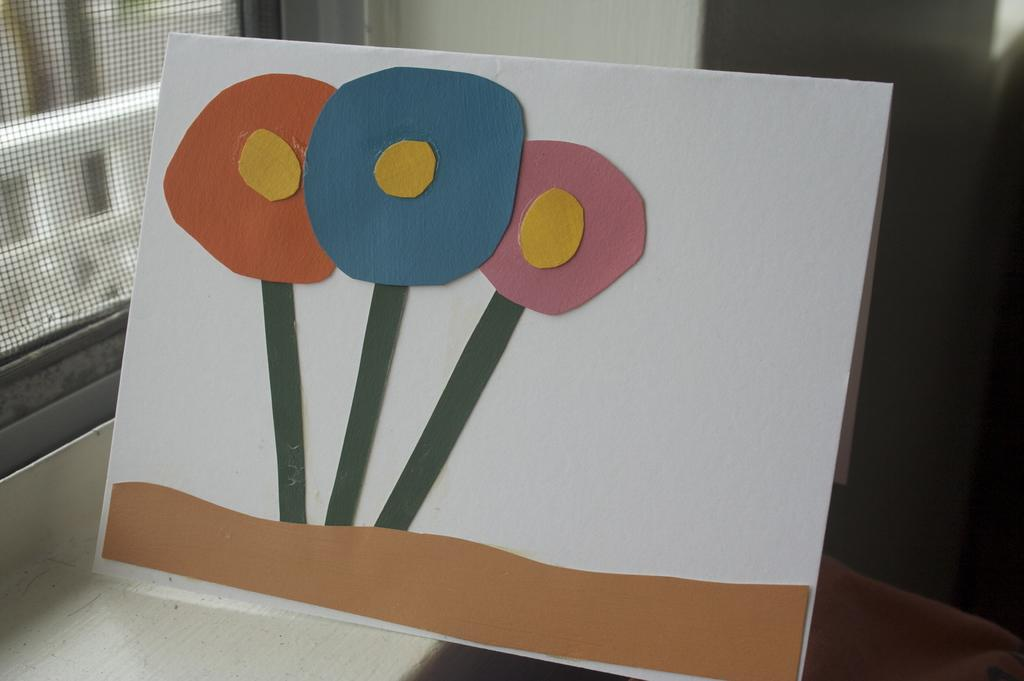What is the main subject of the image? There is a painting in the image. What is the painting placed on? The painting is on a white sheet. Can you describe any additional objects or features in the image? There is a net in the left corner of the image. How many clovers can be seen growing around the tree in the image? There is no tree or clover present in the image; it only features a painting on a white sheet and a net in the left corner. 